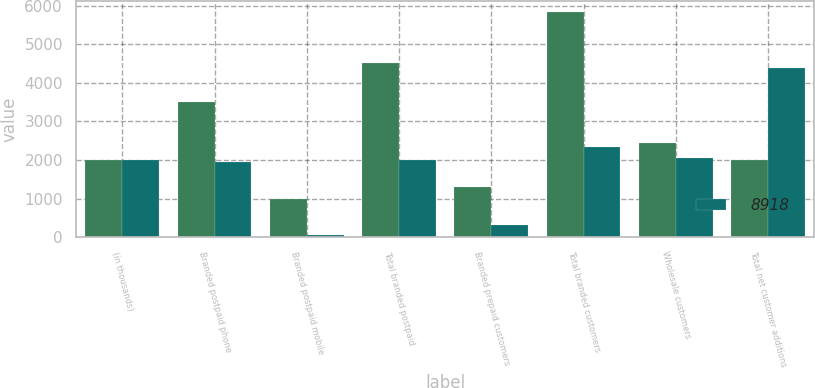<chart> <loc_0><loc_0><loc_500><loc_500><stacked_bar_chart><ecel><fcel>(in thousands)<fcel>Branded postpaid phone<fcel>Branded postpaid mobile<fcel>Total branded postpaid<fcel>Branded prepaid customers<fcel>Total branded customers<fcel>Wholesale customers<fcel>Total net customer additions<nl><fcel>nan<fcel>2015<fcel>3511<fcel>999<fcel>4510<fcel>1315<fcel>5825<fcel>2439<fcel>2015<nl><fcel>8918<fcel>2013<fcel>1938<fcel>68<fcel>2006<fcel>328<fcel>2334<fcel>2043<fcel>4377<nl></chart> 